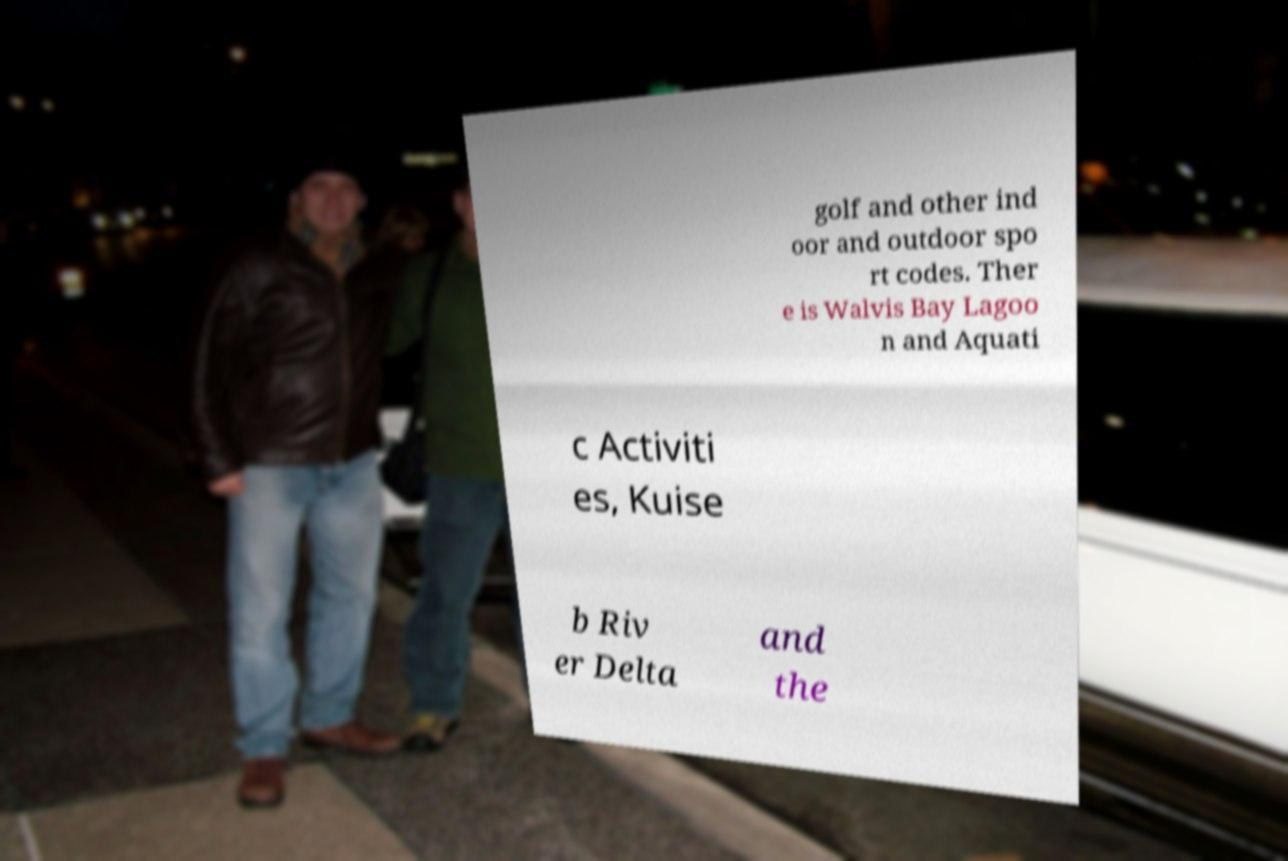I need the written content from this picture converted into text. Can you do that? golf and other ind oor and outdoor spo rt codes. Ther e is Walvis Bay Lagoo n and Aquati c Activiti es, Kuise b Riv er Delta and the 